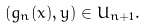Convert formula to latex. <formula><loc_0><loc_0><loc_500><loc_500>( g _ { n } ( x ) , y ) \in U _ { n + 1 } .</formula> 